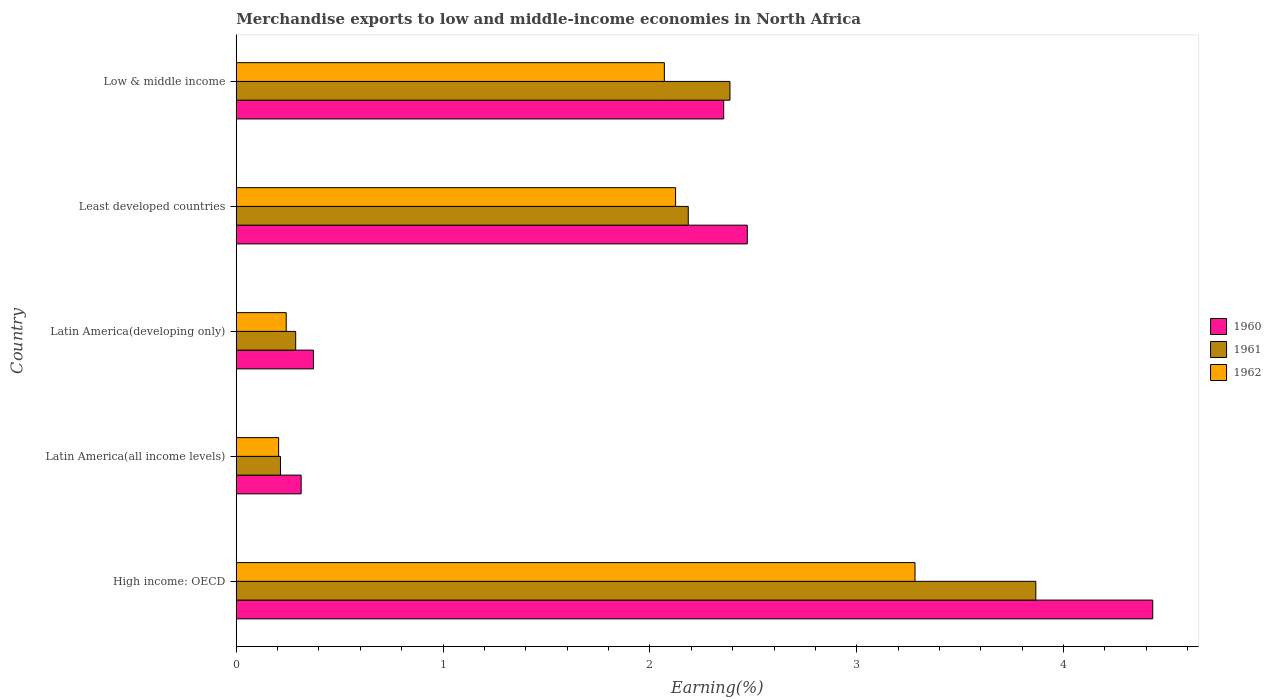How many groups of bars are there?
Keep it short and to the point. 5. Are the number of bars per tick equal to the number of legend labels?
Your answer should be very brief. Yes. How many bars are there on the 2nd tick from the top?
Provide a succinct answer. 3. What is the label of the 1st group of bars from the top?
Provide a short and direct response. Low & middle income. What is the percentage of amount earned from merchandise exports in 1962 in Low & middle income?
Provide a short and direct response. 2.07. Across all countries, what is the maximum percentage of amount earned from merchandise exports in 1960?
Make the answer very short. 4.43. Across all countries, what is the minimum percentage of amount earned from merchandise exports in 1960?
Your answer should be very brief. 0.31. In which country was the percentage of amount earned from merchandise exports in 1962 maximum?
Offer a very short reply. High income: OECD. In which country was the percentage of amount earned from merchandise exports in 1960 minimum?
Your answer should be very brief. Latin America(all income levels). What is the total percentage of amount earned from merchandise exports in 1962 in the graph?
Provide a short and direct response. 7.92. What is the difference between the percentage of amount earned from merchandise exports in 1960 in Latin America(developing only) and that in Low & middle income?
Make the answer very short. -1.98. What is the difference between the percentage of amount earned from merchandise exports in 1960 in High income: OECD and the percentage of amount earned from merchandise exports in 1961 in Latin America(developing only)?
Keep it short and to the point. 4.14. What is the average percentage of amount earned from merchandise exports in 1960 per country?
Offer a terse response. 1.99. What is the difference between the percentage of amount earned from merchandise exports in 1960 and percentage of amount earned from merchandise exports in 1961 in Latin America(all income levels)?
Your answer should be very brief. 0.1. In how many countries, is the percentage of amount earned from merchandise exports in 1961 greater than 2.6 %?
Ensure brevity in your answer.  1. What is the ratio of the percentage of amount earned from merchandise exports in 1961 in High income: OECD to that in Least developed countries?
Keep it short and to the point. 1.77. Is the percentage of amount earned from merchandise exports in 1960 in Latin America(developing only) less than that in Least developed countries?
Ensure brevity in your answer.  Yes. Is the difference between the percentage of amount earned from merchandise exports in 1960 in High income: OECD and Latin America(developing only) greater than the difference between the percentage of amount earned from merchandise exports in 1961 in High income: OECD and Latin America(developing only)?
Your answer should be compact. Yes. What is the difference between the highest and the second highest percentage of amount earned from merchandise exports in 1962?
Offer a terse response. 1.16. What is the difference between the highest and the lowest percentage of amount earned from merchandise exports in 1962?
Your answer should be very brief. 3.08. In how many countries, is the percentage of amount earned from merchandise exports in 1960 greater than the average percentage of amount earned from merchandise exports in 1960 taken over all countries?
Provide a succinct answer. 3. Is the sum of the percentage of amount earned from merchandise exports in 1960 in Latin America(all income levels) and Low & middle income greater than the maximum percentage of amount earned from merchandise exports in 1962 across all countries?
Your response must be concise. No. What does the 1st bar from the bottom in Least developed countries represents?
Make the answer very short. 1960. Is it the case that in every country, the sum of the percentage of amount earned from merchandise exports in 1960 and percentage of amount earned from merchandise exports in 1961 is greater than the percentage of amount earned from merchandise exports in 1962?
Keep it short and to the point. Yes. Are all the bars in the graph horizontal?
Make the answer very short. Yes. What is the difference between two consecutive major ticks on the X-axis?
Give a very brief answer. 1. Are the values on the major ticks of X-axis written in scientific E-notation?
Keep it short and to the point. No. Does the graph contain grids?
Your answer should be very brief. No. How many legend labels are there?
Keep it short and to the point. 3. What is the title of the graph?
Your answer should be compact. Merchandise exports to low and middle-income economies in North Africa. Does "2013" appear as one of the legend labels in the graph?
Your answer should be compact. No. What is the label or title of the X-axis?
Your response must be concise. Earning(%). What is the Earning(%) of 1960 in High income: OECD?
Give a very brief answer. 4.43. What is the Earning(%) in 1961 in High income: OECD?
Give a very brief answer. 3.87. What is the Earning(%) in 1962 in High income: OECD?
Provide a short and direct response. 3.28. What is the Earning(%) in 1960 in Latin America(all income levels)?
Ensure brevity in your answer.  0.31. What is the Earning(%) of 1961 in Latin America(all income levels)?
Provide a short and direct response. 0.21. What is the Earning(%) in 1962 in Latin America(all income levels)?
Keep it short and to the point. 0.2. What is the Earning(%) of 1960 in Latin America(developing only)?
Give a very brief answer. 0.37. What is the Earning(%) in 1961 in Latin America(developing only)?
Offer a very short reply. 0.29. What is the Earning(%) of 1962 in Latin America(developing only)?
Offer a very short reply. 0.24. What is the Earning(%) in 1960 in Least developed countries?
Offer a very short reply. 2.47. What is the Earning(%) of 1961 in Least developed countries?
Provide a succinct answer. 2.19. What is the Earning(%) in 1962 in Least developed countries?
Make the answer very short. 2.12. What is the Earning(%) of 1960 in Low & middle income?
Your response must be concise. 2.36. What is the Earning(%) in 1961 in Low & middle income?
Offer a terse response. 2.39. What is the Earning(%) in 1962 in Low & middle income?
Offer a very short reply. 2.07. Across all countries, what is the maximum Earning(%) in 1960?
Keep it short and to the point. 4.43. Across all countries, what is the maximum Earning(%) in 1961?
Make the answer very short. 3.87. Across all countries, what is the maximum Earning(%) in 1962?
Make the answer very short. 3.28. Across all countries, what is the minimum Earning(%) of 1960?
Your response must be concise. 0.31. Across all countries, what is the minimum Earning(%) in 1961?
Your answer should be compact. 0.21. Across all countries, what is the minimum Earning(%) of 1962?
Ensure brevity in your answer.  0.2. What is the total Earning(%) of 1960 in the graph?
Offer a terse response. 9.94. What is the total Earning(%) of 1961 in the graph?
Provide a short and direct response. 8.94. What is the total Earning(%) in 1962 in the graph?
Give a very brief answer. 7.92. What is the difference between the Earning(%) of 1960 in High income: OECD and that in Latin America(all income levels)?
Make the answer very short. 4.12. What is the difference between the Earning(%) of 1961 in High income: OECD and that in Latin America(all income levels)?
Your answer should be very brief. 3.65. What is the difference between the Earning(%) in 1962 in High income: OECD and that in Latin America(all income levels)?
Your answer should be compact. 3.08. What is the difference between the Earning(%) of 1960 in High income: OECD and that in Latin America(developing only)?
Your answer should be compact. 4.06. What is the difference between the Earning(%) in 1961 in High income: OECD and that in Latin America(developing only)?
Offer a terse response. 3.58. What is the difference between the Earning(%) of 1962 in High income: OECD and that in Latin America(developing only)?
Give a very brief answer. 3.04. What is the difference between the Earning(%) of 1960 in High income: OECD and that in Least developed countries?
Ensure brevity in your answer.  1.96. What is the difference between the Earning(%) in 1961 in High income: OECD and that in Least developed countries?
Make the answer very short. 1.68. What is the difference between the Earning(%) in 1962 in High income: OECD and that in Least developed countries?
Your answer should be compact. 1.16. What is the difference between the Earning(%) of 1960 in High income: OECD and that in Low & middle income?
Your answer should be compact. 2.07. What is the difference between the Earning(%) in 1961 in High income: OECD and that in Low & middle income?
Your response must be concise. 1.48. What is the difference between the Earning(%) in 1962 in High income: OECD and that in Low & middle income?
Keep it short and to the point. 1.21. What is the difference between the Earning(%) in 1960 in Latin America(all income levels) and that in Latin America(developing only)?
Offer a very short reply. -0.06. What is the difference between the Earning(%) in 1961 in Latin America(all income levels) and that in Latin America(developing only)?
Offer a terse response. -0.07. What is the difference between the Earning(%) in 1962 in Latin America(all income levels) and that in Latin America(developing only)?
Your answer should be compact. -0.04. What is the difference between the Earning(%) in 1960 in Latin America(all income levels) and that in Least developed countries?
Ensure brevity in your answer.  -2.16. What is the difference between the Earning(%) in 1961 in Latin America(all income levels) and that in Least developed countries?
Provide a succinct answer. -1.97. What is the difference between the Earning(%) of 1962 in Latin America(all income levels) and that in Least developed countries?
Keep it short and to the point. -1.92. What is the difference between the Earning(%) of 1960 in Latin America(all income levels) and that in Low & middle income?
Offer a terse response. -2.04. What is the difference between the Earning(%) of 1961 in Latin America(all income levels) and that in Low & middle income?
Your answer should be compact. -2.17. What is the difference between the Earning(%) in 1962 in Latin America(all income levels) and that in Low & middle income?
Keep it short and to the point. -1.86. What is the difference between the Earning(%) of 1960 in Latin America(developing only) and that in Least developed countries?
Offer a very short reply. -2.1. What is the difference between the Earning(%) of 1961 in Latin America(developing only) and that in Least developed countries?
Make the answer very short. -1.9. What is the difference between the Earning(%) in 1962 in Latin America(developing only) and that in Least developed countries?
Make the answer very short. -1.88. What is the difference between the Earning(%) of 1960 in Latin America(developing only) and that in Low & middle income?
Offer a terse response. -1.98. What is the difference between the Earning(%) in 1961 in Latin America(developing only) and that in Low & middle income?
Provide a succinct answer. -2.1. What is the difference between the Earning(%) in 1962 in Latin America(developing only) and that in Low & middle income?
Your answer should be compact. -1.83. What is the difference between the Earning(%) in 1960 in Least developed countries and that in Low & middle income?
Keep it short and to the point. 0.11. What is the difference between the Earning(%) in 1961 in Least developed countries and that in Low & middle income?
Your answer should be very brief. -0.2. What is the difference between the Earning(%) of 1962 in Least developed countries and that in Low & middle income?
Your answer should be very brief. 0.05. What is the difference between the Earning(%) of 1960 in High income: OECD and the Earning(%) of 1961 in Latin America(all income levels)?
Offer a terse response. 4.22. What is the difference between the Earning(%) in 1960 in High income: OECD and the Earning(%) in 1962 in Latin America(all income levels)?
Your answer should be very brief. 4.23. What is the difference between the Earning(%) of 1961 in High income: OECD and the Earning(%) of 1962 in Latin America(all income levels)?
Your answer should be very brief. 3.66. What is the difference between the Earning(%) of 1960 in High income: OECD and the Earning(%) of 1961 in Latin America(developing only)?
Make the answer very short. 4.14. What is the difference between the Earning(%) in 1960 in High income: OECD and the Earning(%) in 1962 in Latin America(developing only)?
Provide a short and direct response. 4.19. What is the difference between the Earning(%) in 1961 in High income: OECD and the Earning(%) in 1962 in Latin America(developing only)?
Ensure brevity in your answer.  3.62. What is the difference between the Earning(%) of 1960 in High income: OECD and the Earning(%) of 1961 in Least developed countries?
Your response must be concise. 2.25. What is the difference between the Earning(%) of 1960 in High income: OECD and the Earning(%) of 1962 in Least developed countries?
Make the answer very short. 2.31. What is the difference between the Earning(%) of 1961 in High income: OECD and the Earning(%) of 1962 in Least developed countries?
Your answer should be very brief. 1.74. What is the difference between the Earning(%) of 1960 in High income: OECD and the Earning(%) of 1961 in Low & middle income?
Keep it short and to the point. 2.04. What is the difference between the Earning(%) of 1960 in High income: OECD and the Earning(%) of 1962 in Low & middle income?
Give a very brief answer. 2.36. What is the difference between the Earning(%) of 1961 in High income: OECD and the Earning(%) of 1962 in Low & middle income?
Provide a succinct answer. 1.8. What is the difference between the Earning(%) in 1960 in Latin America(all income levels) and the Earning(%) in 1961 in Latin America(developing only)?
Offer a terse response. 0.03. What is the difference between the Earning(%) in 1960 in Latin America(all income levels) and the Earning(%) in 1962 in Latin America(developing only)?
Your answer should be compact. 0.07. What is the difference between the Earning(%) of 1961 in Latin America(all income levels) and the Earning(%) of 1962 in Latin America(developing only)?
Provide a succinct answer. -0.03. What is the difference between the Earning(%) in 1960 in Latin America(all income levels) and the Earning(%) in 1961 in Least developed countries?
Keep it short and to the point. -1.87. What is the difference between the Earning(%) in 1960 in Latin America(all income levels) and the Earning(%) in 1962 in Least developed countries?
Offer a terse response. -1.81. What is the difference between the Earning(%) of 1961 in Latin America(all income levels) and the Earning(%) of 1962 in Least developed countries?
Provide a succinct answer. -1.91. What is the difference between the Earning(%) of 1960 in Latin America(all income levels) and the Earning(%) of 1961 in Low & middle income?
Provide a short and direct response. -2.07. What is the difference between the Earning(%) in 1960 in Latin America(all income levels) and the Earning(%) in 1962 in Low & middle income?
Your answer should be very brief. -1.76. What is the difference between the Earning(%) of 1961 in Latin America(all income levels) and the Earning(%) of 1962 in Low & middle income?
Offer a terse response. -1.86. What is the difference between the Earning(%) in 1960 in Latin America(developing only) and the Earning(%) in 1961 in Least developed countries?
Offer a terse response. -1.81. What is the difference between the Earning(%) in 1960 in Latin America(developing only) and the Earning(%) in 1962 in Least developed countries?
Make the answer very short. -1.75. What is the difference between the Earning(%) of 1961 in Latin America(developing only) and the Earning(%) of 1962 in Least developed countries?
Your answer should be very brief. -1.84. What is the difference between the Earning(%) in 1960 in Latin America(developing only) and the Earning(%) in 1961 in Low & middle income?
Your answer should be compact. -2.01. What is the difference between the Earning(%) in 1960 in Latin America(developing only) and the Earning(%) in 1962 in Low & middle income?
Ensure brevity in your answer.  -1.7. What is the difference between the Earning(%) in 1961 in Latin America(developing only) and the Earning(%) in 1962 in Low & middle income?
Ensure brevity in your answer.  -1.78. What is the difference between the Earning(%) in 1960 in Least developed countries and the Earning(%) in 1961 in Low & middle income?
Ensure brevity in your answer.  0.08. What is the difference between the Earning(%) in 1960 in Least developed countries and the Earning(%) in 1962 in Low & middle income?
Your answer should be very brief. 0.4. What is the difference between the Earning(%) of 1961 in Least developed countries and the Earning(%) of 1962 in Low & middle income?
Make the answer very short. 0.12. What is the average Earning(%) in 1960 per country?
Your answer should be compact. 1.99. What is the average Earning(%) of 1961 per country?
Make the answer very short. 1.79. What is the average Earning(%) in 1962 per country?
Your answer should be compact. 1.58. What is the difference between the Earning(%) in 1960 and Earning(%) in 1961 in High income: OECD?
Your response must be concise. 0.57. What is the difference between the Earning(%) in 1960 and Earning(%) in 1962 in High income: OECD?
Your response must be concise. 1.15. What is the difference between the Earning(%) in 1961 and Earning(%) in 1962 in High income: OECD?
Offer a terse response. 0.58. What is the difference between the Earning(%) of 1960 and Earning(%) of 1961 in Latin America(all income levels)?
Keep it short and to the point. 0.1. What is the difference between the Earning(%) in 1960 and Earning(%) in 1962 in Latin America(all income levels)?
Your response must be concise. 0.11. What is the difference between the Earning(%) of 1961 and Earning(%) of 1962 in Latin America(all income levels)?
Provide a short and direct response. 0.01. What is the difference between the Earning(%) of 1960 and Earning(%) of 1961 in Latin America(developing only)?
Your response must be concise. 0.09. What is the difference between the Earning(%) in 1960 and Earning(%) in 1962 in Latin America(developing only)?
Give a very brief answer. 0.13. What is the difference between the Earning(%) in 1961 and Earning(%) in 1962 in Latin America(developing only)?
Keep it short and to the point. 0.05. What is the difference between the Earning(%) in 1960 and Earning(%) in 1961 in Least developed countries?
Give a very brief answer. 0.29. What is the difference between the Earning(%) of 1960 and Earning(%) of 1962 in Least developed countries?
Ensure brevity in your answer.  0.35. What is the difference between the Earning(%) in 1961 and Earning(%) in 1962 in Least developed countries?
Keep it short and to the point. 0.06. What is the difference between the Earning(%) in 1960 and Earning(%) in 1961 in Low & middle income?
Keep it short and to the point. -0.03. What is the difference between the Earning(%) of 1960 and Earning(%) of 1962 in Low & middle income?
Provide a succinct answer. 0.29. What is the difference between the Earning(%) of 1961 and Earning(%) of 1962 in Low & middle income?
Offer a terse response. 0.32. What is the ratio of the Earning(%) in 1960 in High income: OECD to that in Latin America(all income levels)?
Ensure brevity in your answer.  14.12. What is the ratio of the Earning(%) in 1961 in High income: OECD to that in Latin America(all income levels)?
Provide a succinct answer. 18.08. What is the ratio of the Earning(%) in 1962 in High income: OECD to that in Latin America(all income levels)?
Your answer should be compact. 16.01. What is the ratio of the Earning(%) of 1960 in High income: OECD to that in Latin America(developing only)?
Make the answer very short. 11.88. What is the ratio of the Earning(%) of 1961 in High income: OECD to that in Latin America(developing only)?
Make the answer very short. 13.45. What is the ratio of the Earning(%) of 1962 in High income: OECD to that in Latin America(developing only)?
Make the answer very short. 13.58. What is the ratio of the Earning(%) in 1960 in High income: OECD to that in Least developed countries?
Give a very brief answer. 1.79. What is the ratio of the Earning(%) of 1961 in High income: OECD to that in Least developed countries?
Your answer should be compact. 1.77. What is the ratio of the Earning(%) in 1962 in High income: OECD to that in Least developed countries?
Make the answer very short. 1.54. What is the ratio of the Earning(%) of 1960 in High income: OECD to that in Low & middle income?
Offer a very short reply. 1.88. What is the ratio of the Earning(%) in 1961 in High income: OECD to that in Low & middle income?
Keep it short and to the point. 1.62. What is the ratio of the Earning(%) in 1962 in High income: OECD to that in Low & middle income?
Offer a very short reply. 1.59. What is the ratio of the Earning(%) of 1960 in Latin America(all income levels) to that in Latin America(developing only)?
Give a very brief answer. 0.84. What is the ratio of the Earning(%) in 1961 in Latin America(all income levels) to that in Latin America(developing only)?
Give a very brief answer. 0.74. What is the ratio of the Earning(%) in 1962 in Latin America(all income levels) to that in Latin America(developing only)?
Give a very brief answer. 0.85. What is the ratio of the Earning(%) in 1960 in Latin America(all income levels) to that in Least developed countries?
Your answer should be compact. 0.13. What is the ratio of the Earning(%) in 1961 in Latin America(all income levels) to that in Least developed countries?
Give a very brief answer. 0.1. What is the ratio of the Earning(%) in 1962 in Latin America(all income levels) to that in Least developed countries?
Keep it short and to the point. 0.1. What is the ratio of the Earning(%) in 1960 in Latin America(all income levels) to that in Low & middle income?
Your answer should be compact. 0.13. What is the ratio of the Earning(%) of 1961 in Latin America(all income levels) to that in Low & middle income?
Your answer should be very brief. 0.09. What is the ratio of the Earning(%) in 1962 in Latin America(all income levels) to that in Low & middle income?
Keep it short and to the point. 0.1. What is the ratio of the Earning(%) in 1960 in Latin America(developing only) to that in Least developed countries?
Give a very brief answer. 0.15. What is the ratio of the Earning(%) of 1961 in Latin America(developing only) to that in Least developed countries?
Your answer should be very brief. 0.13. What is the ratio of the Earning(%) in 1962 in Latin America(developing only) to that in Least developed countries?
Offer a terse response. 0.11. What is the ratio of the Earning(%) of 1960 in Latin America(developing only) to that in Low & middle income?
Give a very brief answer. 0.16. What is the ratio of the Earning(%) in 1961 in Latin America(developing only) to that in Low & middle income?
Provide a succinct answer. 0.12. What is the ratio of the Earning(%) of 1962 in Latin America(developing only) to that in Low & middle income?
Your answer should be very brief. 0.12. What is the ratio of the Earning(%) in 1960 in Least developed countries to that in Low & middle income?
Your answer should be compact. 1.05. What is the ratio of the Earning(%) in 1961 in Least developed countries to that in Low & middle income?
Your answer should be compact. 0.92. What is the ratio of the Earning(%) in 1962 in Least developed countries to that in Low & middle income?
Ensure brevity in your answer.  1.03. What is the difference between the highest and the second highest Earning(%) in 1960?
Your response must be concise. 1.96. What is the difference between the highest and the second highest Earning(%) in 1961?
Give a very brief answer. 1.48. What is the difference between the highest and the second highest Earning(%) in 1962?
Your answer should be very brief. 1.16. What is the difference between the highest and the lowest Earning(%) in 1960?
Ensure brevity in your answer.  4.12. What is the difference between the highest and the lowest Earning(%) in 1961?
Offer a very short reply. 3.65. What is the difference between the highest and the lowest Earning(%) of 1962?
Give a very brief answer. 3.08. 